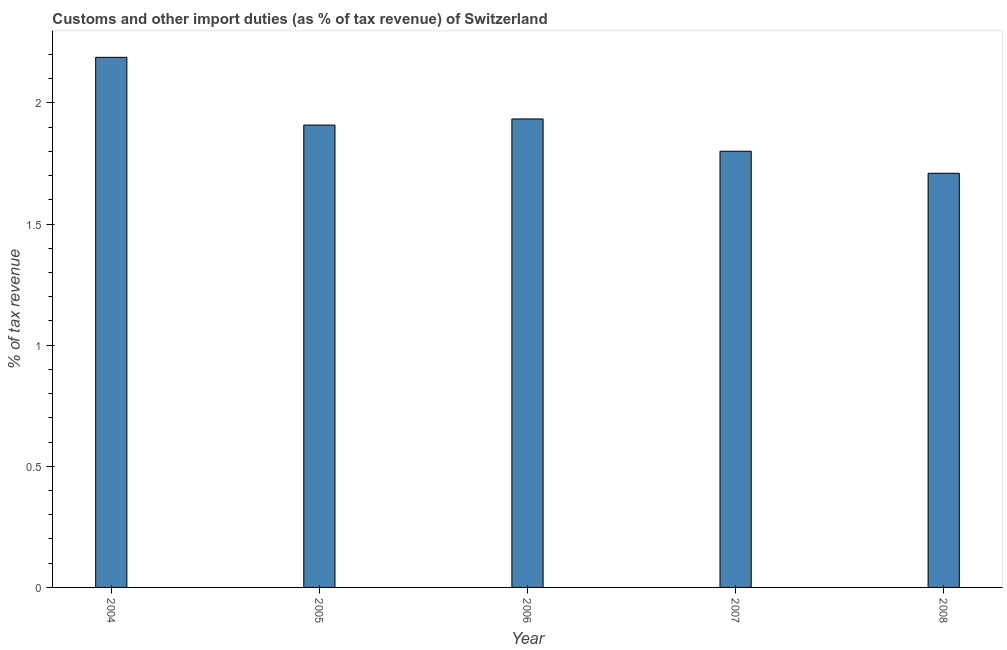Does the graph contain grids?
Provide a succinct answer. No. What is the title of the graph?
Ensure brevity in your answer.  Customs and other import duties (as % of tax revenue) of Switzerland. What is the label or title of the X-axis?
Provide a succinct answer. Year. What is the label or title of the Y-axis?
Provide a succinct answer. % of tax revenue. What is the customs and other import duties in 2008?
Offer a very short reply. 1.71. Across all years, what is the maximum customs and other import duties?
Offer a terse response. 2.19. Across all years, what is the minimum customs and other import duties?
Give a very brief answer. 1.71. In which year was the customs and other import duties maximum?
Your answer should be very brief. 2004. In which year was the customs and other import duties minimum?
Provide a short and direct response. 2008. What is the sum of the customs and other import duties?
Your response must be concise. 9.54. What is the difference between the customs and other import duties in 2004 and 2006?
Your answer should be very brief. 0.25. What is the average customs and other import duties per year?
Offer a very short reply. 1.91. What is the median customs and other import duties?
Keep it short and to the point. 1.91. Do a majority of the years between 2008 and 2004 (inclusive) have customs and other import duties greater than 0.8 %?
Give a very brief answer. Yes. What is the ratio of the customs and other import duties in 2006 to that in 2007?
Provide a succinct answer. 1.07. Is the difference between the customs and other import duties in 2004 and 2005 greater than the difference between any two years?
Your response must be concise. No. What is the difference between the highest and the second highest customs and other import duties?
Your answer should be very brief. 0.25. Is the sum of the customs and other import duties in 2005 and 2006 greater than the maximum customs and other import duties across all years?
Provide a short and direct response. Yes. What is the difference between the highest and the lowest customs and other import duties?
Ensure brevity in your answer.  0.48. How many years are there in the graph?
Give a very brief answer. 5. What is the difference between two consecutive major ticks on the Y-axis?
Make the answer very short. 0.5. Are the values on the major ticks of Y-axis written in scientific E-notation?
Keep it short and to the point. No. What is the % of tax revenue of 2004?
Ensure brevity in your answer.  2.19. What is the % of tax revenue of 2005?
Provide a succinct answer. 1.91. What is the % of tax revenue in 2006?
Give a very brief answer. 1.93. What is the % of tax revenue in 2007?
Your answer should be very brief. 1.8. What is the % of tax revenue of 2008?
Provide a short and direct response. 1.71. What is the difference between the % of tax revenue in 2004 and 2005?
Give a very brief answer. 0.28. What is the difference between the % of tax revenue in 2004 and 2006?
Provide a succinct answer. 0.25. What is the difference between the % of tax revenue in 2004 and 2007?
Make the answer very short. 0.39. What is the difference between the % of tax revenue in 2004 and 2008?
Offer a terse response. 0.48. What is the difference between the % of tax revenue in 2005 and 2006?
Make the answer very short. -0.03. What is the difference between the % of tax revenue in 2005 and 2007?
Make the answer very short. 0.11. What is the difference between the % of tax revenue in 2005 and 2008?
Give a very brief answer. 0.2. What is the difference between the % of tax revenue in 2006 and 2007?
Keep it short and to the point. 0.13. What is the difference between the % of tax revenue in 2006 and 2008?
Make the answer very short. 0.22. What is the difference between the % of tax revenue in 2007 and 2008?
Give a very brief answer. 0.09. What is the ratio of the % of tax revenue in 2004 to that in 2005?
Your answer should be compact. 1.15. What is the ratio of the % of tax revenue in 2004 to that in 2006?
Offer a terse response. 1.13. What is the ratio of the % of tax revenue in 2004 to that in 2007?
Provide a succinct answer. 1.22. What is the ratio of the % of tax revenue in 2004 to that in 2008?
Ensure brevity in your answer.  1.28. What is the ratio of the % of tax revenue in 2005 to that in 2007?
Your answer should be compact. 1.06. What is the ratio of the % of tax revenue in 2005 to that in 2008?
Provide a succinct answer. 1.12. What is the ratio of the % of tax revenue in 2006 to that in 2007?
Give a very brief answer. 1.07. What is the ratio of the % of tax revenue in 2006 to that in 2008?
Your answer should be compact. 1.13. What is the ratio of the % of tax revenue in 2007 to that in 2008?
Offer a terse response. 1.05. 